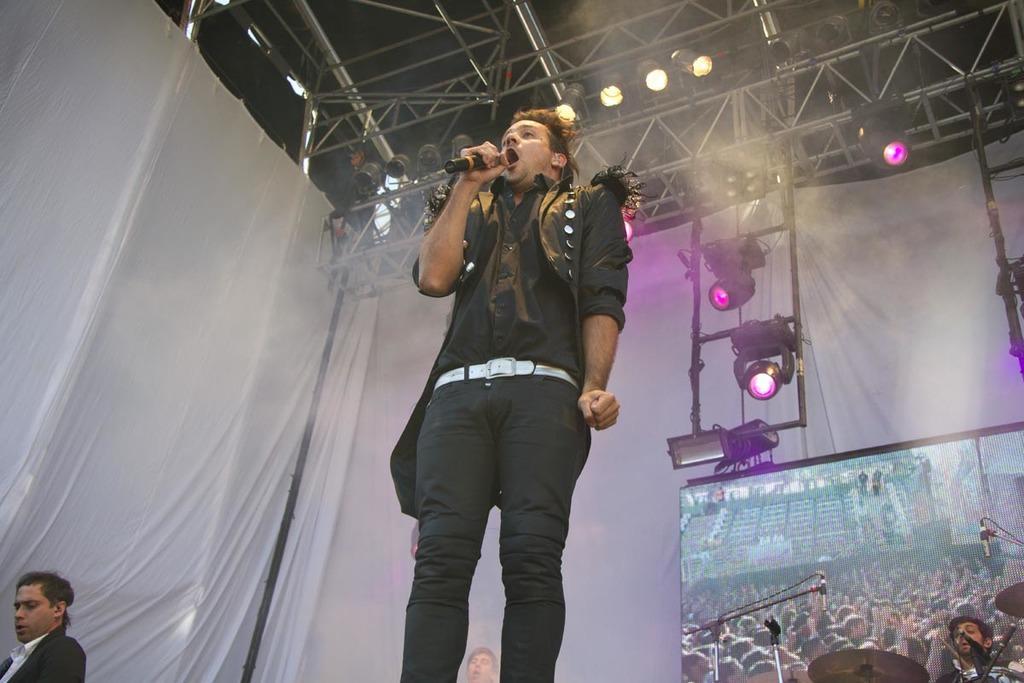How would you summarize this image in a sentence or two? In this image I can see a man is standing and singing in the microphone. He wore black color coat, trouser. On the right side there are focus lights. 